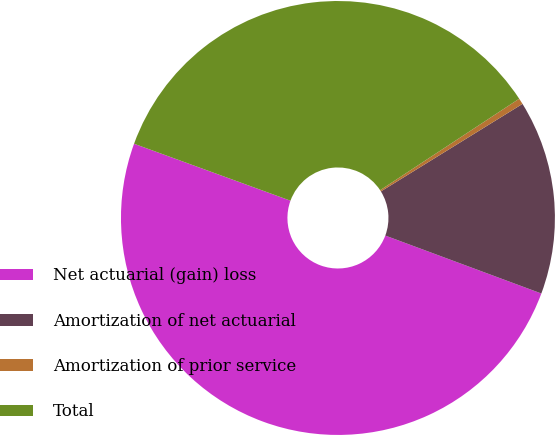<chart> <loc_0><loc_0><loc_500><loc_500><pie_chart><fcel>Net actuarial (gain) loss<fcel>Amortization of net actuarial<fcel>Amortization of prior service<fcel>Total<nl><fcel>49.9%<fcel>14.47%<fcel>0.45%<fcel>35.18%<nl></chart> 